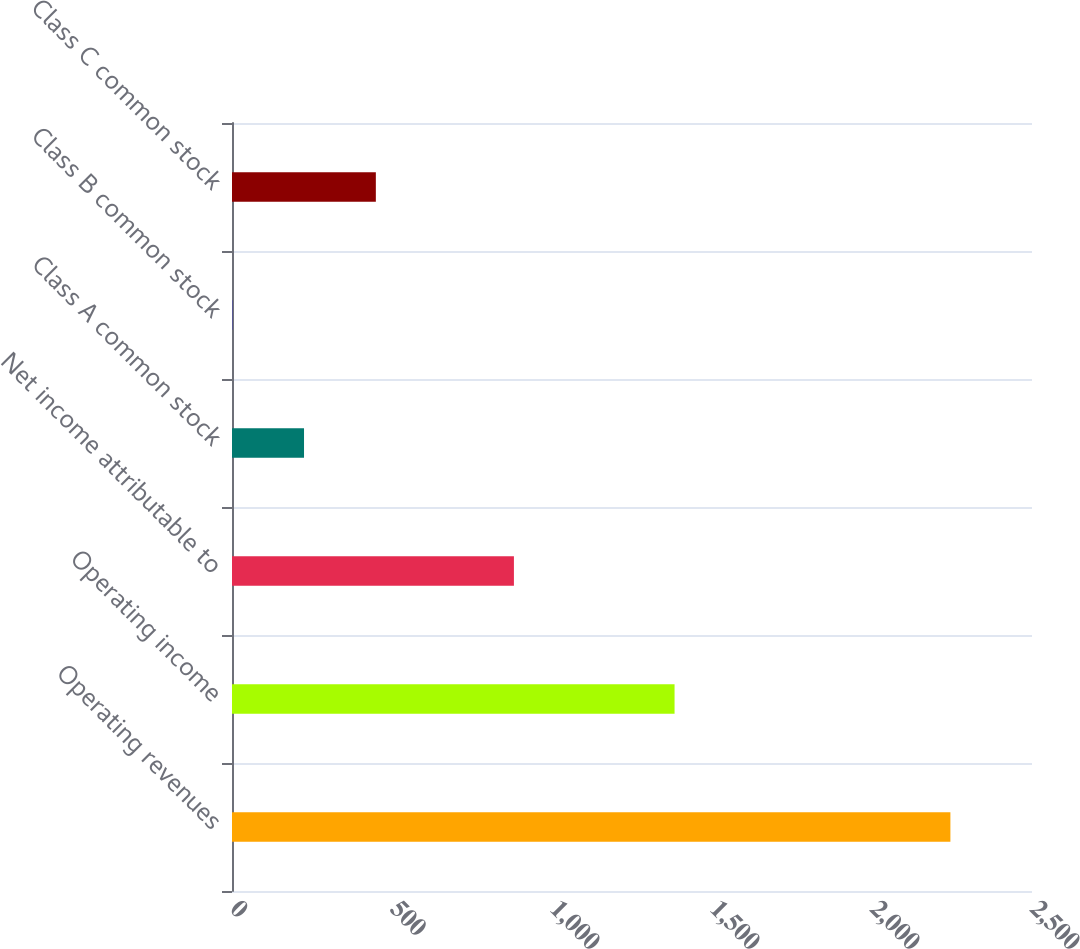<chart> <loc_0><loc_0><loc_500><loc_500><bar_chart><fcel>Operating revenues<fcel>Operating income<fcel>Net income attributable to<fcel>Class A common stock<fcel>Class B common stock<fcel>Class C common stock<nl><fcel>2245<fcel>1383<fcel>881<fcel>225.07<fcel>0.63<fcel>449.51<nl></chart> 